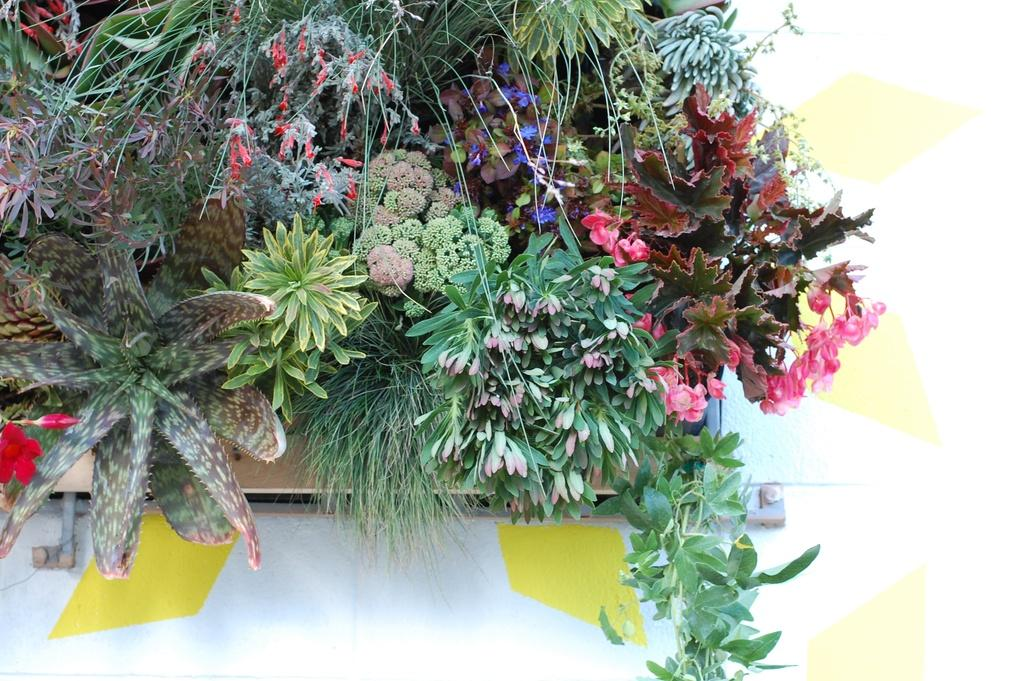What type of clothing is visible in the image? There are pants in the image. What type of plant is present in the image? There are flowers in a flower pot in the image. What piece of furniture is at the bottom of the image? There is a table at the bottom of the image. What type of jelly is being served on the table in the image? There is no jelly present in the image; it only features pants, flowers in a pot, and a table. Is there a band playing music in the image? There is no band present in the image. 